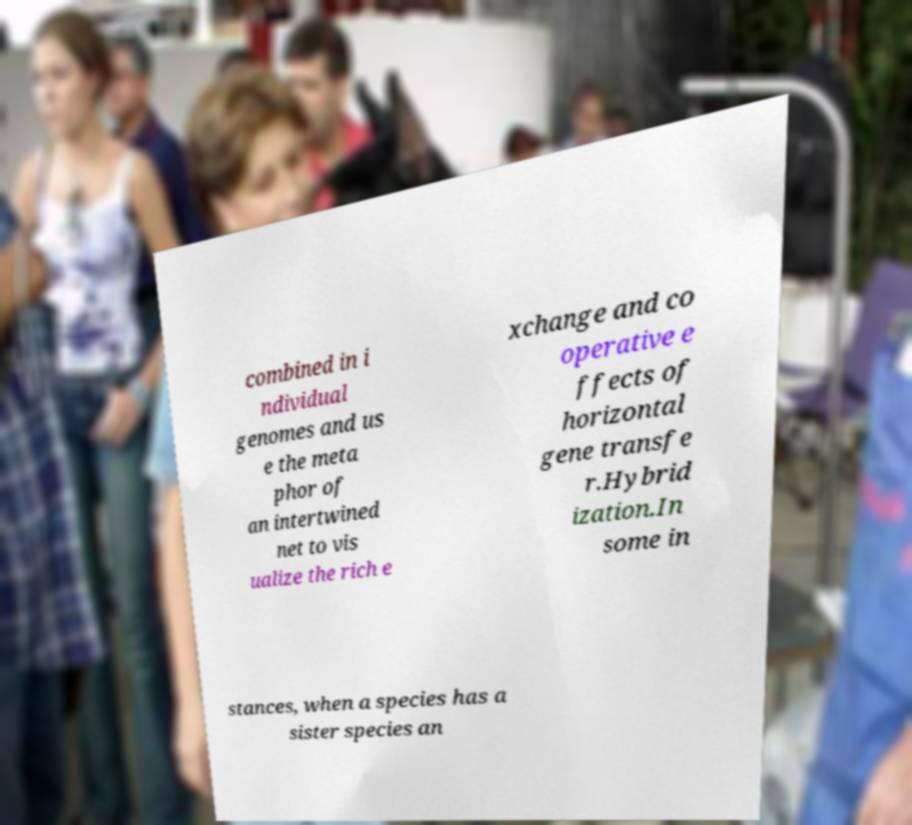Please identify and transcribe the text found in this image. combined in i ndividual genomes and us e the meta phor of an intertwined net to vis ualize the rich e xchange and co operative e ffects of horizontal gene transfe r.Hybrid ization.In some in stances, when a species has a sister species an 